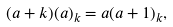Convert formula to latex. <formula><loc_0><loc_0><loc_500><loc_500>( a + k ) ( a ) _ { k } = a ( a + 1 ) _ { k } ,</formula> 